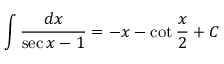Convert formula to latex. <formula><loc_0><loc_0><loc_500><loc_500>\int { \frac { d x } { \sec { x } - 1 } } = - x - \cot { \frac { x } { 2 } } + C</formula> 